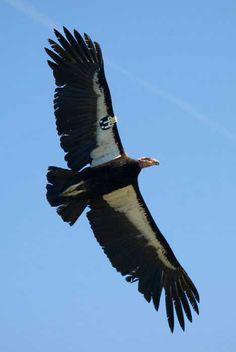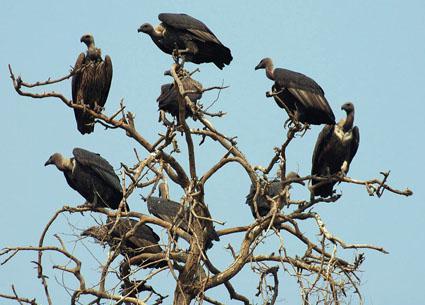The first image is the image on the left, the second image is the image on the right. For the images shown, is this caption "There are three birds, two of which are facing left, and one of which is facing right." true? Answer yes or no. No. The first image is the image on the left, the second image is the image on the right. For the images displayed, is the sentence "There is a bird in flight not touching the ground." factually correct? Answer yes or no. Yes. 